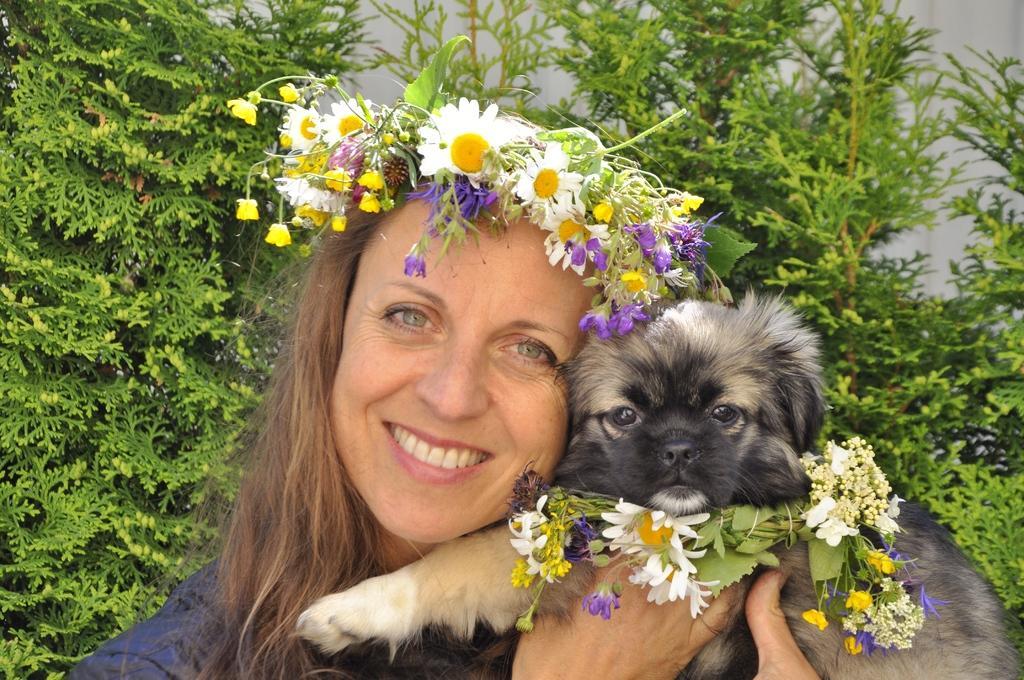Can you describe this image briefly? In this picture one woman is standing and holding a dog and she is wearing one flower crown and the dog is also wearing one flower garland around the neck and behind them there are plants. 